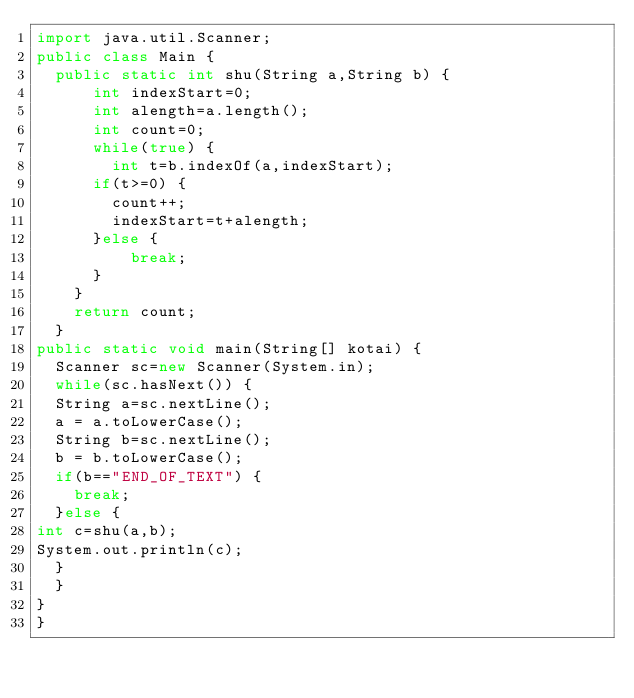Convert code to text. <code><loc_0><loc_0><loc_500><loc_500><_Java_>import java.util.Scanner;
public class Main {
	public static int shu(String a,String b) {
			int indexStart=0;
			int alength=a.length();
			int count=0;
			while(true) {
				int t=b.indexOf(a,indexStart);
			if(t>=0) {
				count++;
				indexStart=t+alength;
			}else {
					break;
			}
		}
		return count;
	}
public static void main(String[] kotai) {
	Scanner sc=new Scanner(System.in);
	while(sc.hasNext()) {
	String a=sc.nextLine();
	a = a.toLowerCase();
	String b=sc.nextLine();
	b = b.toLowerCase();
	if(b=="END_OF_TEXT") {
		break;
	}else {
int c=shu(a,b);
System.out.println(c);
	}
	}
}
}
</code> 